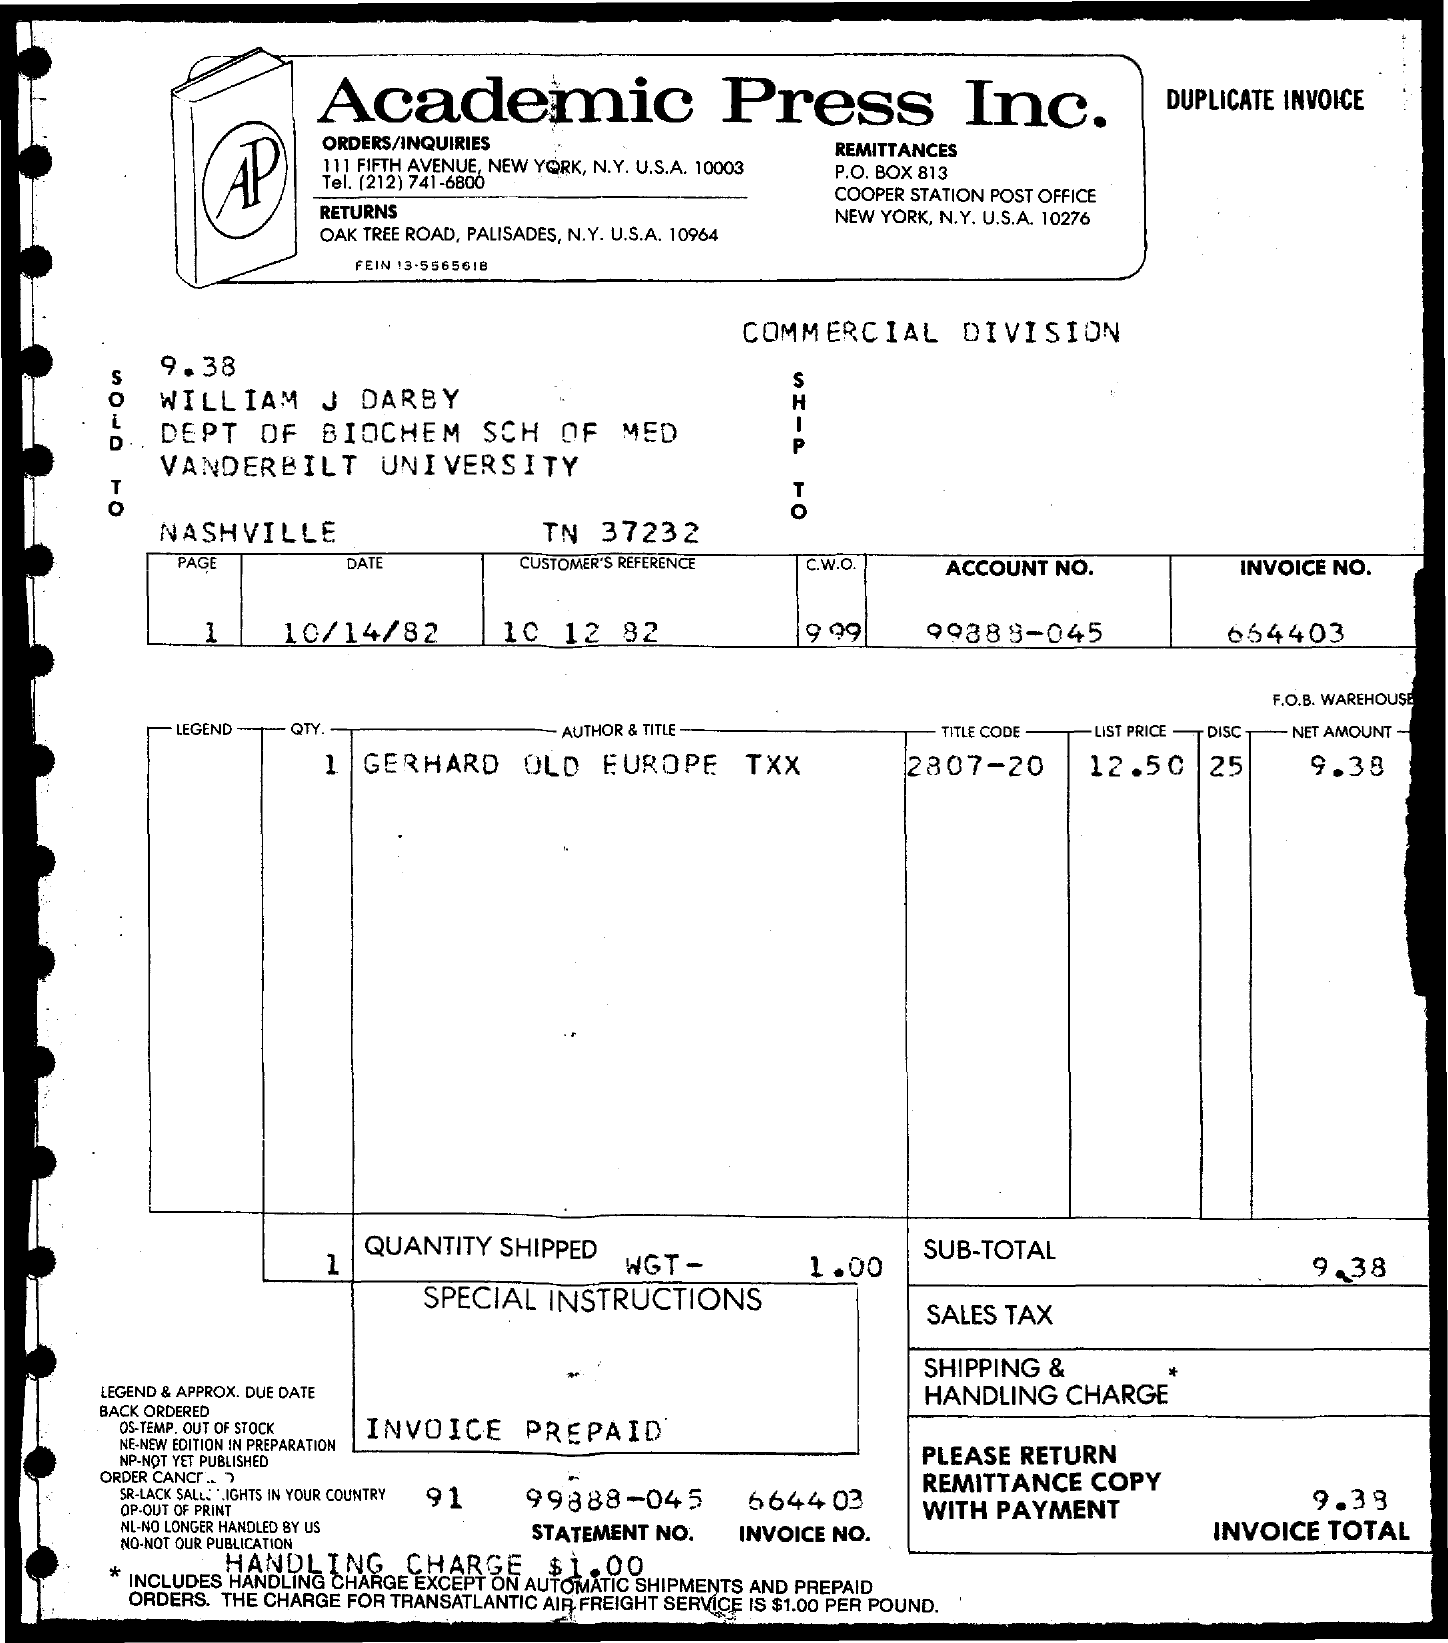What is the shipping and handling charge on this invoice? The invoice outlines a shipping and handling charge of $0.00, indicating there was no extra fee for shipping and handling for this order. 